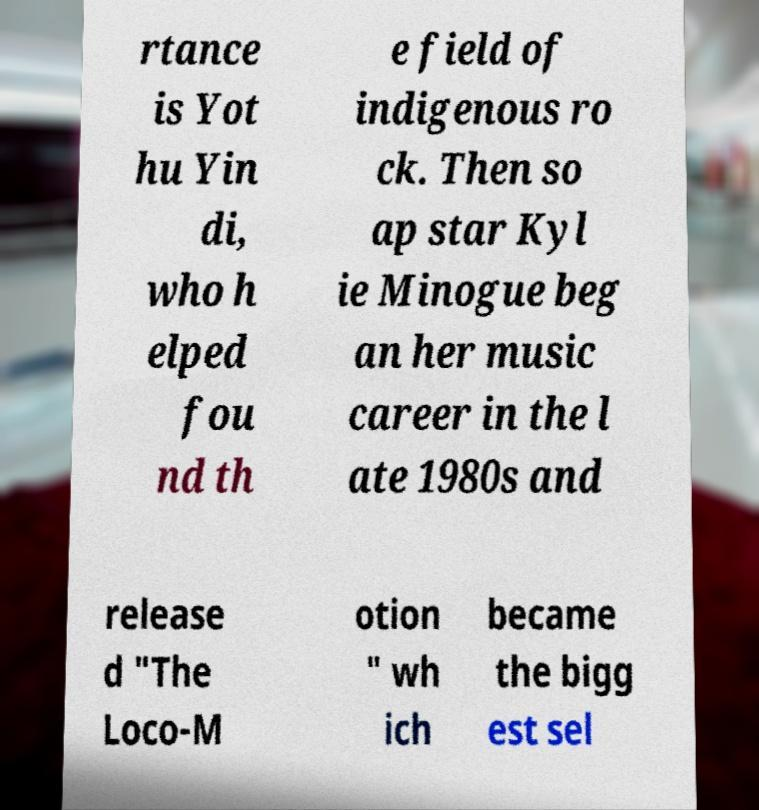Can you accurately transcribe the text from the provided image for me? rtance is Yot hu Yin di, who h elped fou nd th e field of indigenous ro ck. Then so ap star Kyl ie Minogue beg an her music career in the l ate 1980s and release d "The Loco-M otion " wh ich became the bigg est sel 